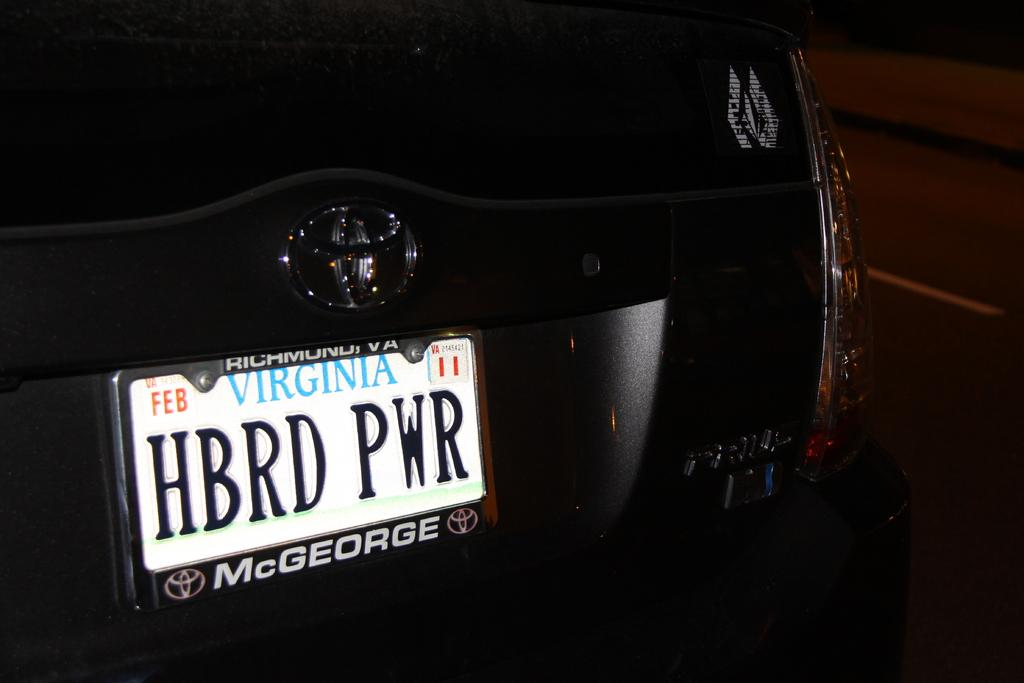<image>
Write a terse but informative summary of the picture. A Virginia license plate is in a McGeorge license plate frame. 